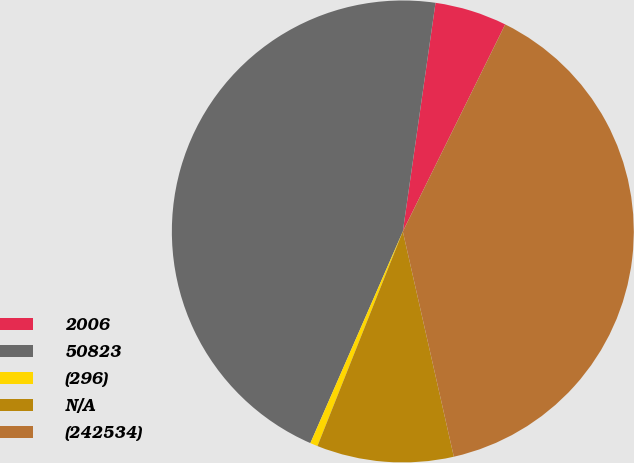<chart> <loc_0><loc_0><loc_500><loc_500><pie_chart><fcel>2006<fcel>50823<fcel>(296)<fcel>N/A<fcel>(242534)<nl><fcel>5.05%<fcel>45.71%<fcel>0.53%<fcel>9.57%<fcel>39.15%<nl></chart> 